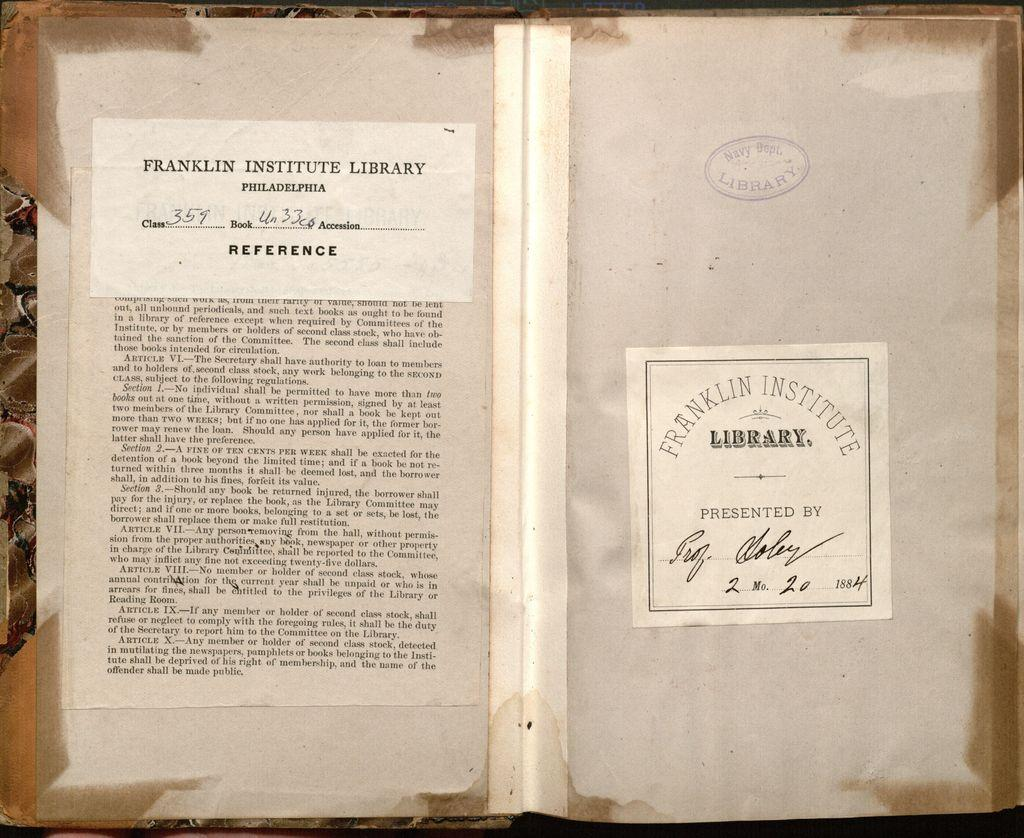<image>
Give a short and clear explanation of the subsequent image. A reference from the Franklin Institute Library of Philadelphia that is dated 1884. 